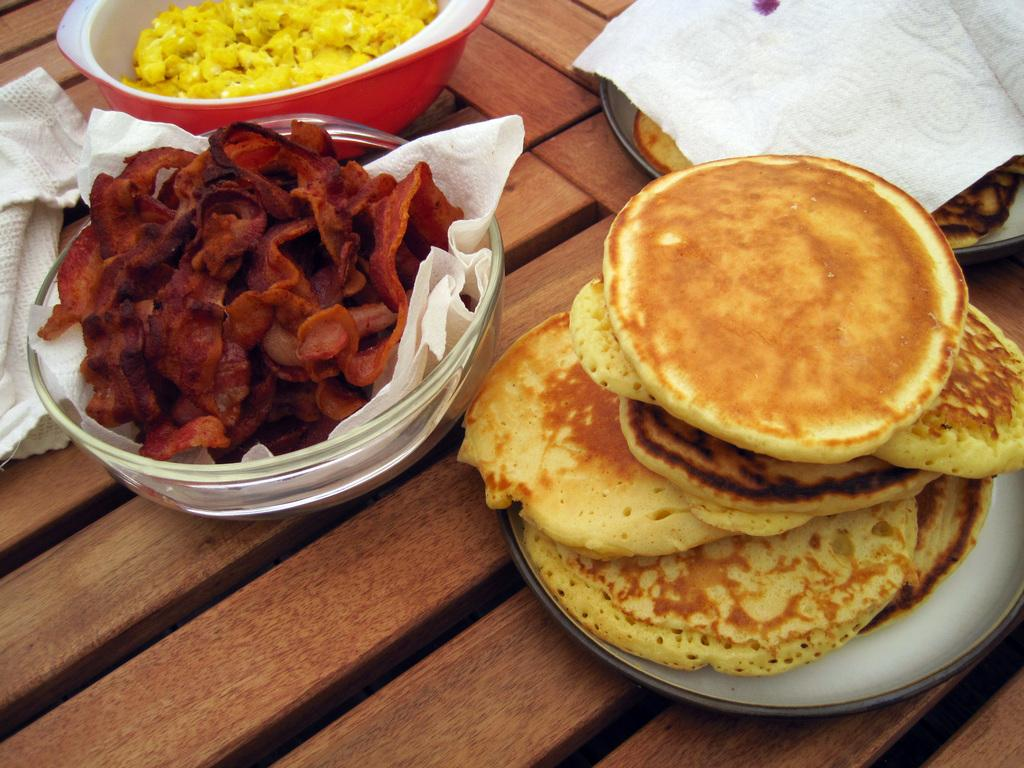What type of dishware can be seen in the image? There are bowls and plates in the image. What is contained in the vessel in the image? The vessel contains food items. Are there any items for cleaning or drying in the image? Paper towels may be present in the image. Can you determine the time of day when the image was taken? The image may have been taken during the day. How does the beetle grip the plate in the image? There is no beetle present in the image, so it cannot be determined how a beetle would grip the plate. 